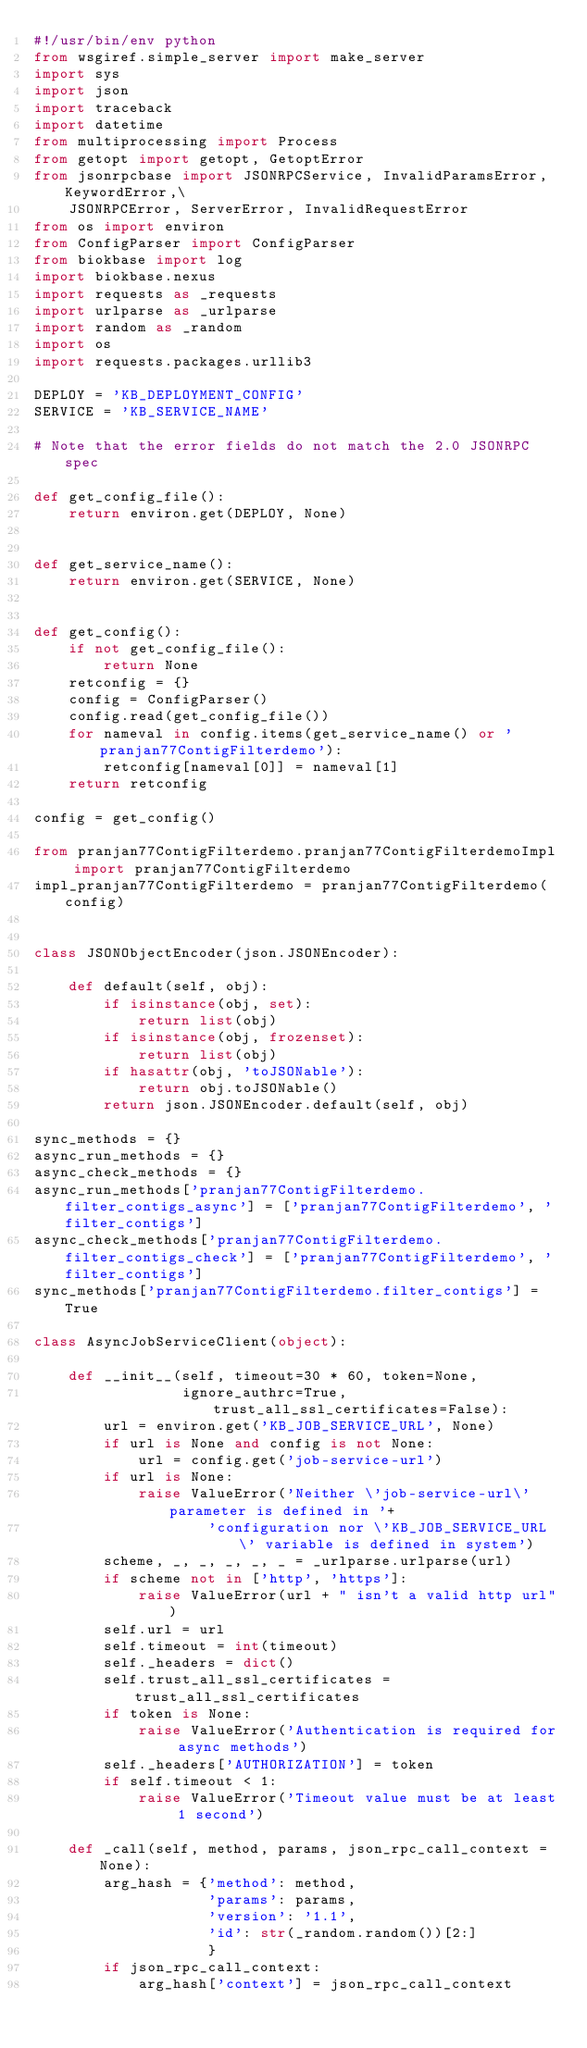<code> <loc_0><loc_0><loc_500><loc_500><_Python_>#!/usr/bin/env python
from wsgiref.simple_server import make_server
import sys
import json
import traceback
import datetime
from multiprocessing import Process
from getopt import getopt, GetoptError
from jsonrpcbase import JSONRPCService, InvalidParamsError, KeywordError,\
    JSONRPCError, ServerError, InvalidRequestError
from os import environ
from ConfigParser import ConfigParser
from biokbase import log
import biokbase.nexus
import requests as _requests
import urlparse as _urlparse
import random as _random
import os
import requests.packages.urllib3

DEPLOY = 'KB_DEPLOYMENT_CONFIG'
SERVICE = 'KB_SERVICE_NAME'

# Note that the error fields do not match the 2.0 JSONRPC spec

def get_config_file():
    return environ.get(DEPLOY, None)


def get_service_name():
    return environ.get(SERVICE, None)


def get_config():
    if not get_config_file():
        return None
    retconfig = {}
    config = ConfigParser()
    config.read(get_config_file())
    for nameval in config.items(get_service_name() or 'pranjan77ContigFilterdemo'):
        retconfig[nameval[0]] = nameval[1]
    return retconfig

config = get_config()

from pranjan77ContigFilterdemo.pranjan77ContigFilterdemoImpl import pranjan77ContigFilterdemo
impl_pranjan77ContigFilterdemo = pranjan77ContigFilterdemo(config)


class JSONObjectEncoder(json.JSONEncoder):

    def default(self, obj):
        if isinstance(obj, set):
            return list(obj)
        if isinstance(obj, frozenset):
            return list(obj)
        if hasattr(obj, 'toJSONable'):
            return obj.toJSONable()
        return json.JSONEncoder.default(self, obj)

sync_methods = {}
async_run_methods = {}
async_check_methods = {}
async_run_methods['pranjan77ContigFilterdemo.filter_contigs_async'] = ['pranjan77ContigFilterdemo', 'filter_contigs']
async_check_methods['pranjan77ContigFilterdemo.filter_contigs_check'] = ['pranjan77ContigFilterdemo', 'filter_contigs']
sync_methods['pranjan77ContigFilterdemo.filter_contigs'] = True

class AsyncJobServiceClient(object):

    def __init__(self, timeout=30 * 60, token=None,
                 ignore_authrc=True, trust_all_ssl_certificates=False):
        url = environ.get('KB_JOB_SERVICE_URL', None)
        if url is None and config is not None:
            url = config.get('job-service-url')
        if url is None:
            raise ValueError('Neither \'job-service-url\' parameter is defined in '+
                    'configuration nor \'KB_JOB_SERVICE_URL\' variable is defined in system')
        scheme, _, _, _, _, _ = _urlparse.urlparse(url)
        if scheme not in ['http', 'https']:
            raise ValueError(url + " isn't a valid http url")
        self.url = url
        self.timeout = int(timeout)
        self._headers = dict()
        self.trust_all_ssl_certificates = trust_all_ssl_certificates
        if token is None:
            raise ValueError('Authentication is required for async methods')        
        self._headers['AUTHORIZATION'] = token
        if self.timeout < 1:
            raise ValueError('Timeout value must be at least 1 second')

    def _call(self, method, params, json_rpc_call_context = None):
        arg_hash = {'method': method,
                    'params': params,
                    'version': '1.1',
                    'id': str(_random.random())[2:]
                    }
        if json_rpc_call_context:
            arg_hash['context'] = json_rpc_call_context</code> 